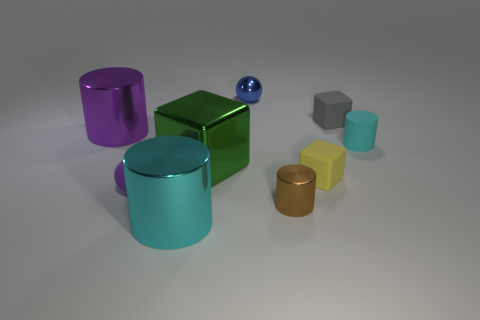How many metallic cylinders are the same color as the small matte cylinder?
Ensure brevity in your answer.  1. What size is the metallic cylinder on the right side of the small metal thing behind the metallic cylinder to the right of the small blue object?
Offer a very short reply. Small. What is the color of the cylinder that is in front of the yellow matte thing and to the left of the big green metal thing?
Offer a terse response. Cyan. Does the yellow matte object have the same size as the cyan thing that is on the left side of the cyan rubber cylinder?
Your answer should be very brief. No. There is another tiny metal object that is the same shape as the tiny cyan object; what is its color?
Provide a succinct answer. Brown. Is the size of the green object the same as the gray matte object?
Your response must be concise. No. What number of other things are the same size as the purple rubber ball?
Make the answer very short. 5. What number of objects are either blocks that are on the right side of the tiny brown thing or small things right of the metal ball?
Offer a very short reply. 4. The purple rubber object that is the same size as the blue shiny object is what shape?
Keep it short and to the point. Sphere. What size is the brown cylinder that is the same material as the large purple object?
Offer a very short reply. Small. 